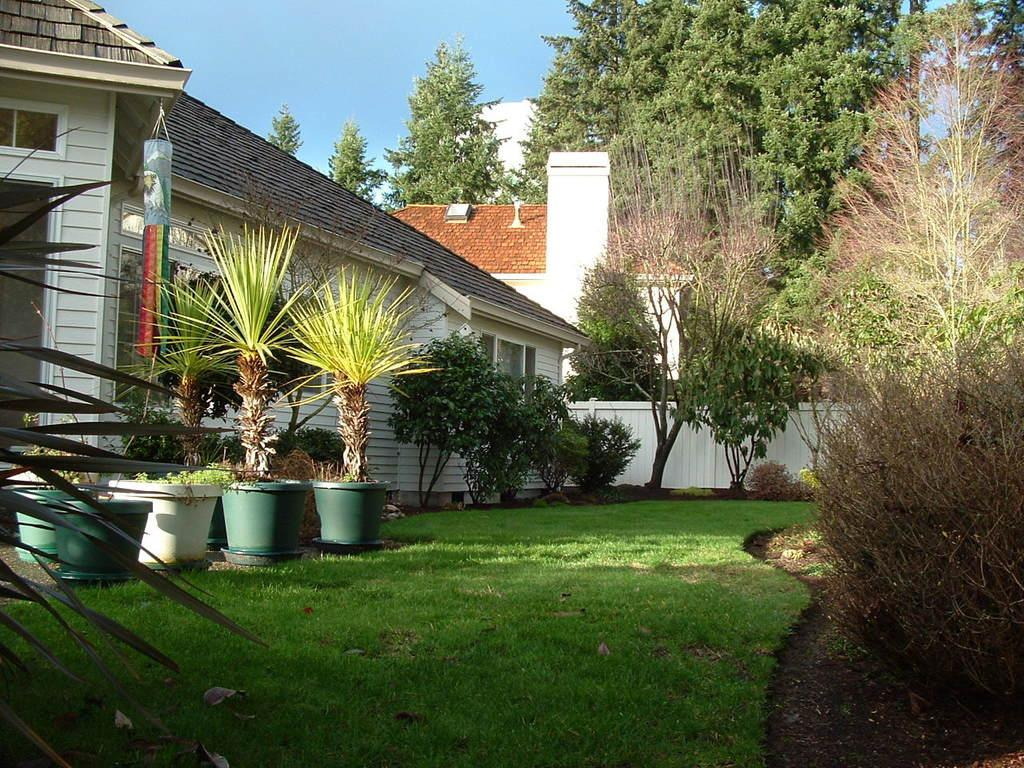What type of location is shown in the image? The image depicts a garden. What can be found in the garden? There are many plants and trees in the garden. What covers the ground in the garden? Grass is present on the ground in the garden. What can be seen in the background of the image? There are houses visible in the background of the image. What is visible at the top of the image? The sky is visible at the top of the image. What type of leather is used to cover the trees in the image? There is: There is no leather present in the image, and the trees are not covered with any material. 